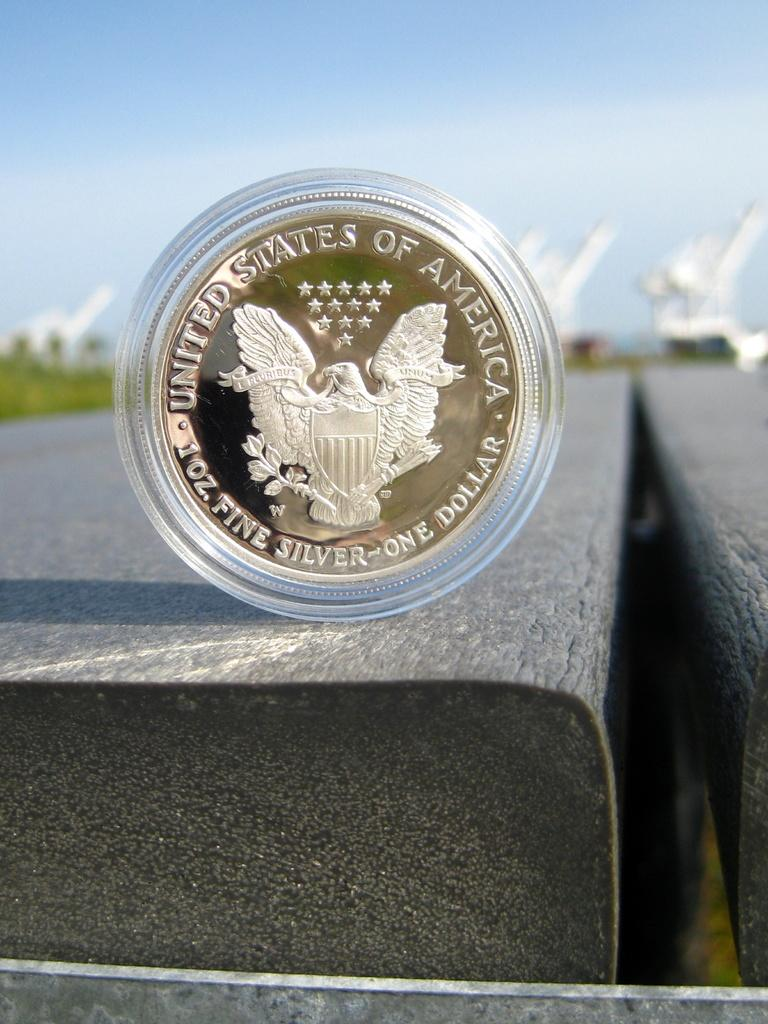<image>
Relay a brief, clear account of the picture shown. A coin for one dollar and 1 oz. fine silver. 